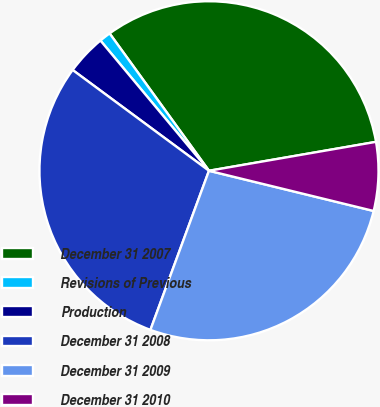Convert chart. <chart><loc_0><loc_0><loc_500><loc_500><pie_chart><fcel>December 31 2007<fcel>Revisions of Previous<fcel>Production<fcel>December 31 2008<fcel>December 31 2009<fcel>December 31 2010<nl><fcel>32.24%<fcel>1.09%<fcel>3.81%<fcel>29.52%<fcel>26.8%<fcel>6.54%<nl></chart> 